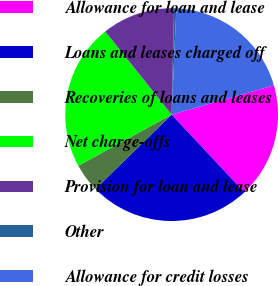<chart> <loc_0><loc_0><loc_500><loc_500><pie_chart><fcel>Allowance for loan and lease<fcel>Loans and leases charged off<fcel>Recoveries of loans and leases<fcel>Net charge-offs<fcel>Provision for loan and lease<fcel>Other<fcel>Allowance for credit losses<nl><fcel>17.46%<fcel>24.67%<fcel>4.32%<fcel>22.26%<fcel>11.09%<fcel>0.34%<fcel>19.86%<nl></chart> 